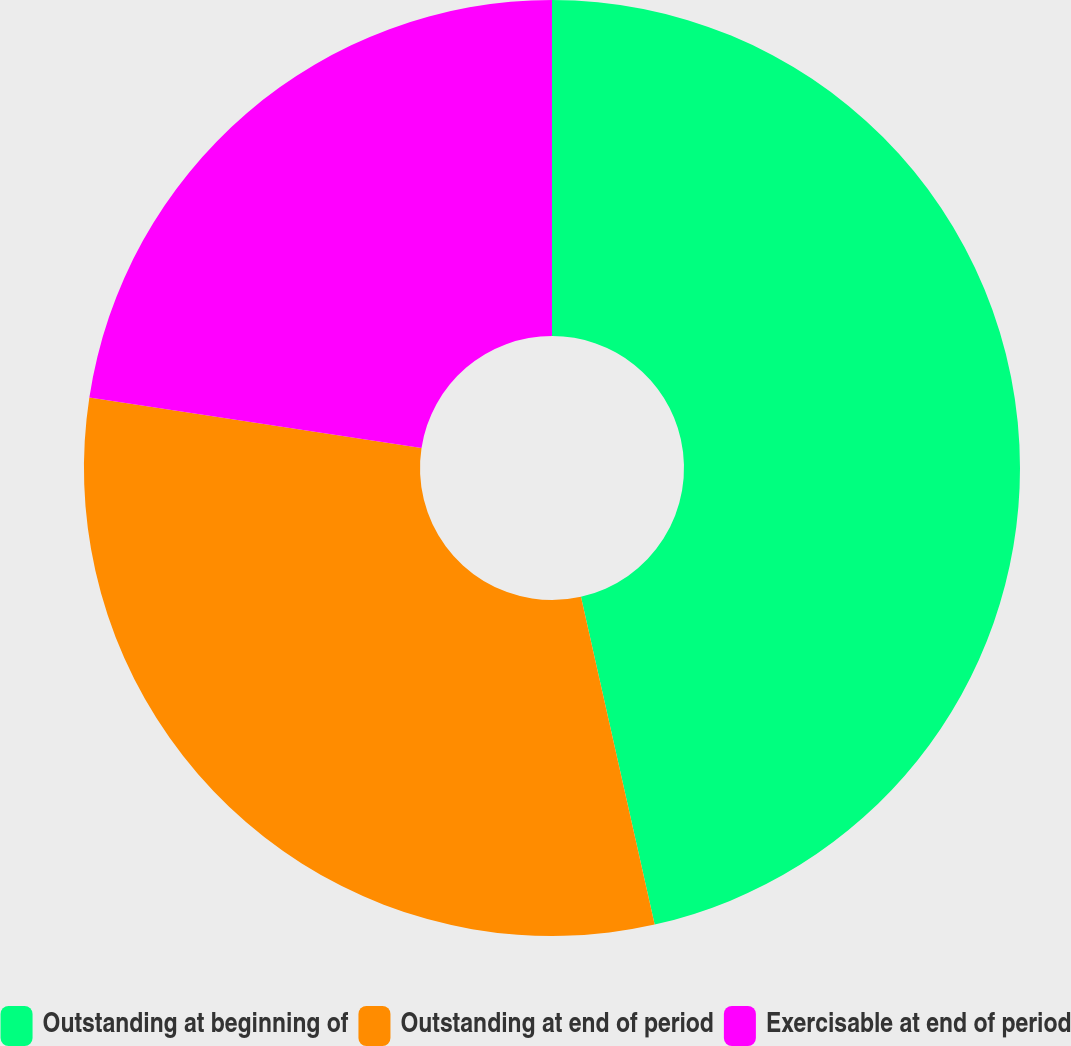Convert chart to OTSL. <chart><loc_0><loc_0><loc_500><loc_500><pie_chart><fcel>Outstanding at beginning of<fcel>Outstanding at end of period<fcel>Exercisable at end of period<nl><fcel>46.48%<fcel>30.93%<fcel>22.59%<nl></chart> 